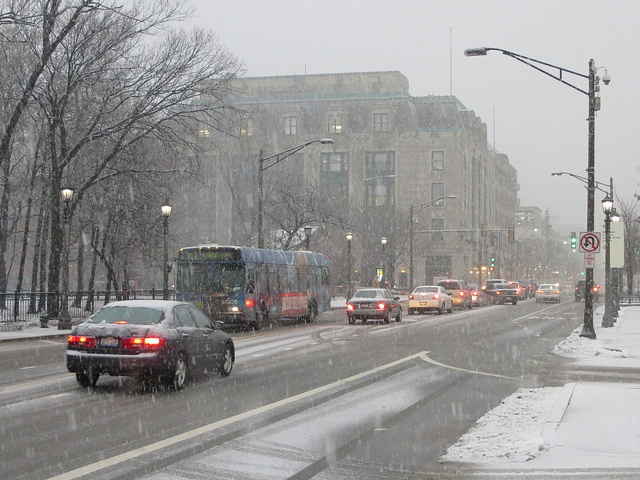Describe the objects in this image and their specific colors. I can see car in lightgray, gray, black, and darkgray tones, bus in lightgray, gray, and black tones, car in lightgray, darkgray, and gray tones, car in lightgray, darkgray, tan, and gray tones, and car in lightgray, gray, darkgray, and tan tones in this image. 